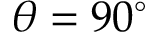<formula> <loc_0><loc_0><loc_500><loc_500>\theta = 9 0 ^ { \circ }</formula> 